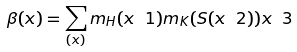<formula> <loc_0><loc_0><loc_500><loc_500>\beta ( x ) = \sum _ { ( x ) } m _ { H } ( x \ 1 ) m _ { K } ( S ( x \ 2 ) ) x \ 3</formula> 